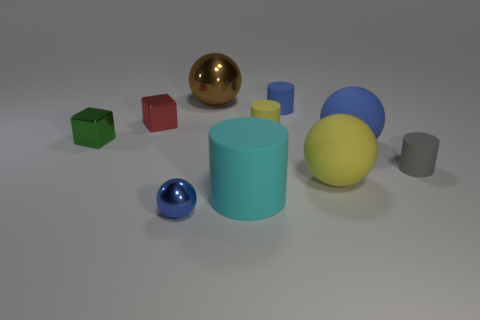What number of objects are either blue spheres behind the large yellow object or big things that are behind the red thing?
Offer a very short reply. 2. Do the big thing left of the cyan cylinder and the large matte object behind the large yellow rubber thing have the same shape?
Offer a very short reply. Yes. What is the shape of the blue metal object that is the same size as the red cube?
Give a very brief answer. Sphere. What number of metal objects are either spheres or green things?
Make the answer very short. 3. Do the small green block to the left of the tiny red cube and the big ball left of the large cyan rubber object have the same material?
Give a very brief answer. Yes. What color is the other big thing that is the same material as the red thing?
Your response must be concise. Brown. Is the number of large spheres behind the tiny blue matte cylinder greater than the number of big shiny spheres behind the yellow sphere?
Keep it short and to the point. No. Are there any small red rubber cylinders?
Give a very brief answer. No. How many things are gray objects or small yellow metal cylinders?
Offer a terse response. 1. Are there any tiny matte things of the same color as the tiny shiny ball?
Provide a succinct answer. Yes. 